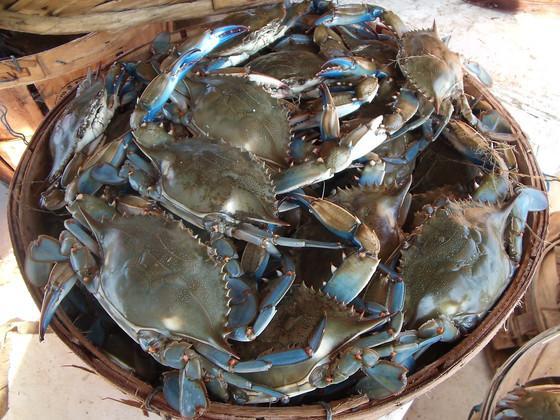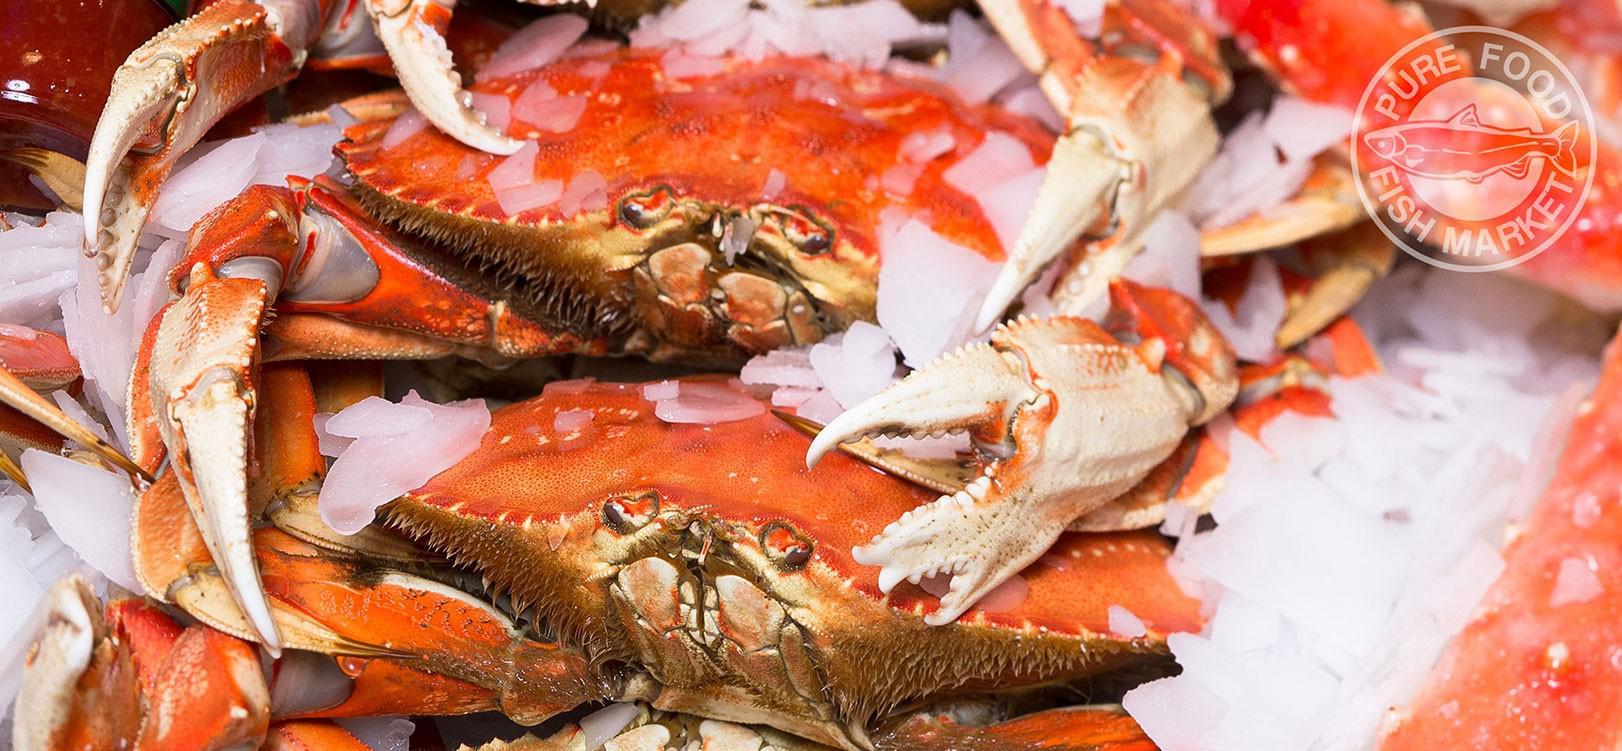The first image is the image on the left, the second image is the image on the right. Given the left and right images, does the statement "There is one pile of gray crabs and one pile of red crabs." hold true? Answer yes or no. Yes. The first image is the image on the left, the second image is the image on the right. Analyze the images presented: Is the assertion "The left image is a top-view of a pile of blue-gray crabs, and the right image is a more head-on view of multiple red-orange crabs." valid? Answer yes or no. Yes. 